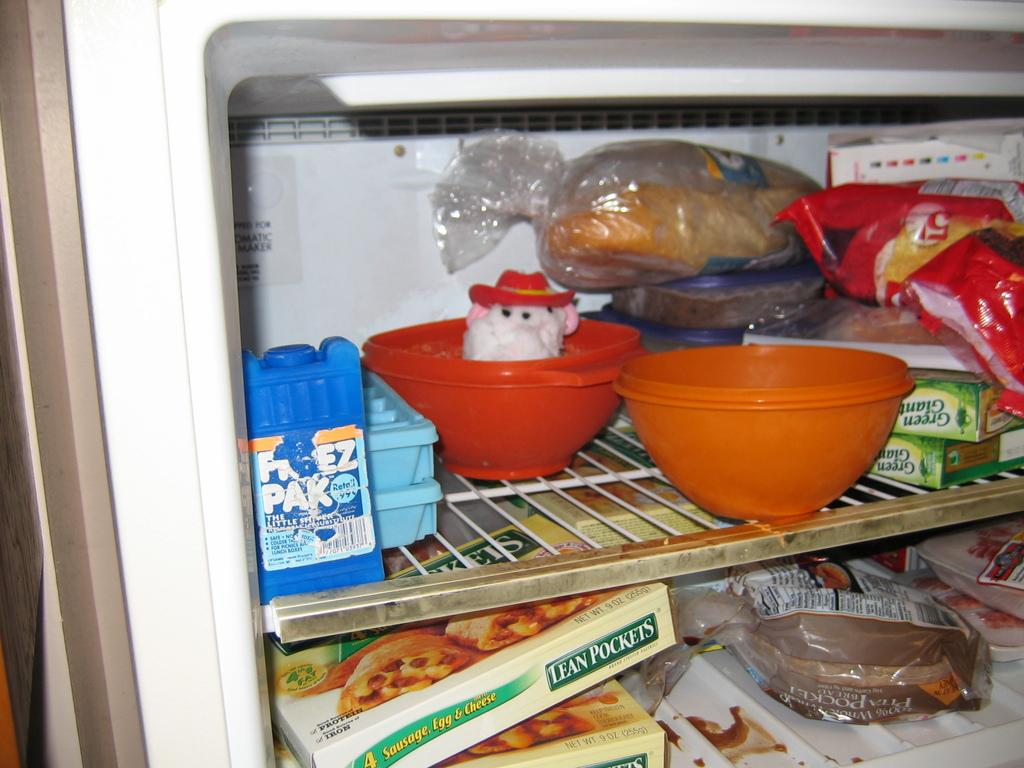What type of appliance is visible in the image? There is a refrigerator in the image. What can be found inside the refrigerator? There are bowls and food inside the refrigerator. How many cattle are visible in the image? There are no cattle present in the image. What type of arch can be seen in the image? There is no arch present in the image. 